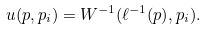<formula> <loc_0><loc_0><loc_500><loc_500>u ( p , p _ { i } ) = W ^ { - 1 } ( \ell ^ { - 1 } ( p ) , p _ { i } ) .</formula> 